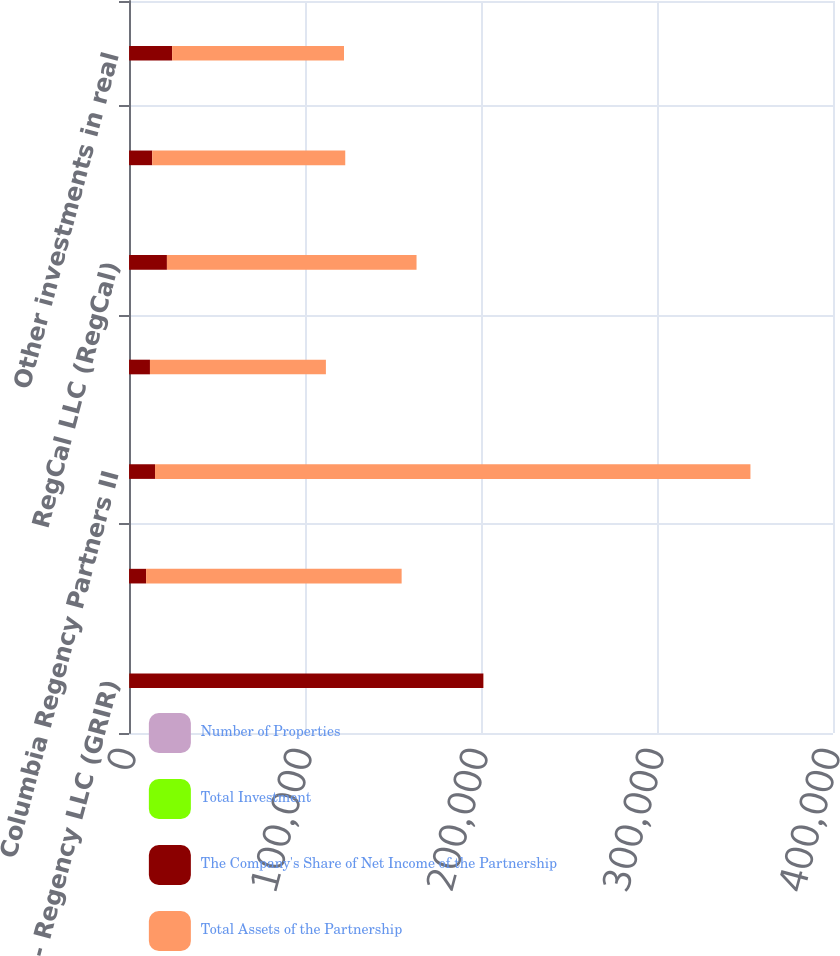Convert chart. <chart><loc_0><loc_0><loc_500><loc_500><stacked_bar_chart><ecel><fcel>GRI - Regency LLC (GRIR)<fcel>Columbia Regency Retail<fcel>Columbia Regency Partners II<fcel>Cameron Village LLC (Cameron)<fcel>RegCal LLC (RegCal)<fcel>US Regency Retail I LLC (USAA)<fcel>Other investments in real<nl><fcel>Number of Properties<fcel>40<fcel>20<fcel>20<fcel>30<fcel>25<fcel>20.01<fcel>50<nl><fcel>Total Investment<fcel>70<fcel>7<fcel>12<fcel>1<fcel>7<fcel>8<fcel>4<nl><fcel>The Company's Share of Net Income of the Partnership<fcel>201240<fcel>9687<fcel>14750<fcel>11877<fcel>21516<fcel>13176<fcel>24453<nl><fcel>Total Assets of the Partnership<fcel>70<fcel>145192<fcel>338307<fcel>99967<fcel>141827<fcel>109665<fcel>97650<nl></chart> 